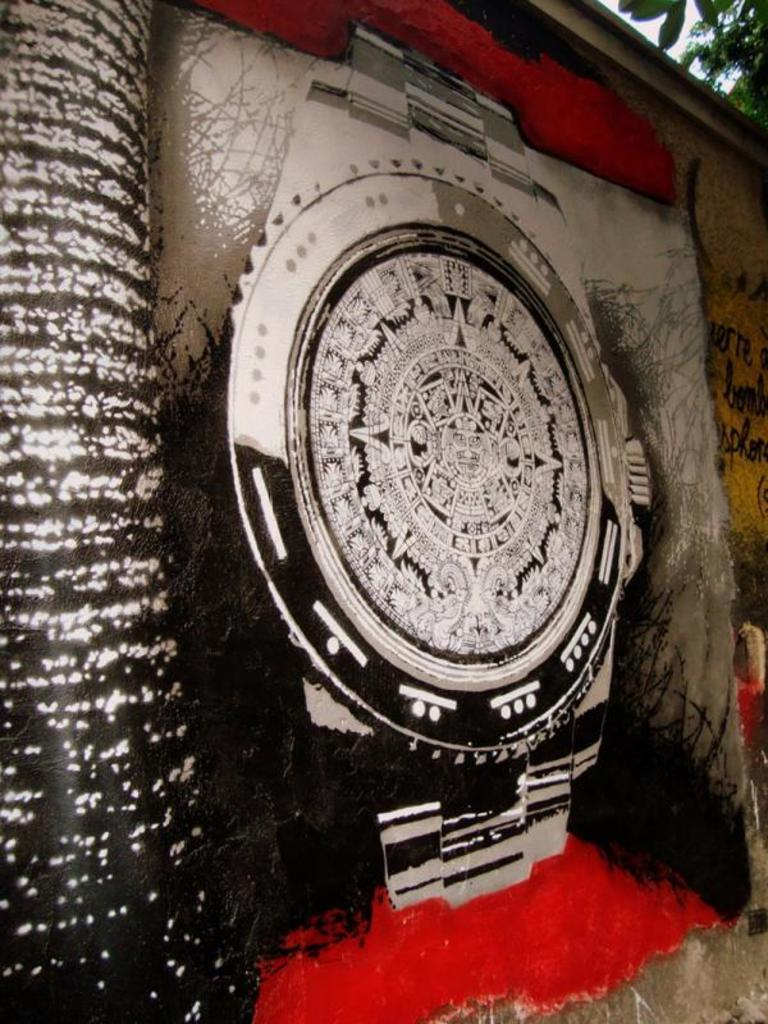What is depicted on the wall in the image? There is a painting on the wall in the image. What is the main subject of the painting? The painting features a watch. Are there any unique features on the watch in the painting? Yes, the watch has designs on its dial. What type of cherries are used to decorate the nation's flag in the image? There are no cherries or flags present in the image; it features a painting of a watch with designs on its dial. 